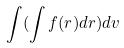<formula> <loc_0><loc_0><loc_500><loc_500>\int ( \int f ( r ) d r ) d v</formula> 